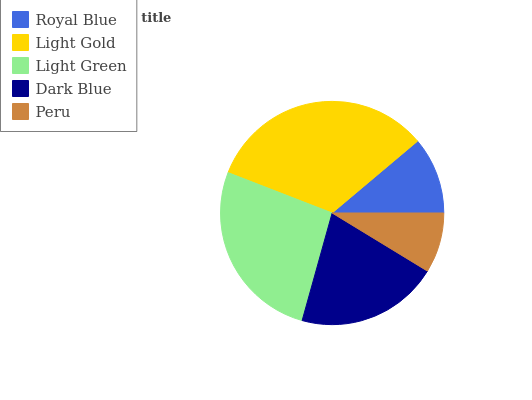Is Peru the minimum?
Answer yes or no. Yes. Is Light Gold the maximum?
Answer yes or no. Yes. Is Light Green the minimum?
Answer yes or no. No. Is Light Green the maximum?
Answer yes or no. No. Is Light Gold greater than Light Green?
Answer yes or no. Yes. Is Light Green less than Light Gold?
Answer yes or no. Yes. Is Light Green greater than Light Gold?
Answer yes or no. No. Is Light Gold less than Light Green?
Answer yes or no. No. Is Dark Blue the high median?
Answer yes or no. Yes. Is Dark Blue the low median?
Answer yes or no. Yes. Is Light Green the high median?
Answer yes or no. No. Is Light Gold the low median?
Answer yes or no. No. 